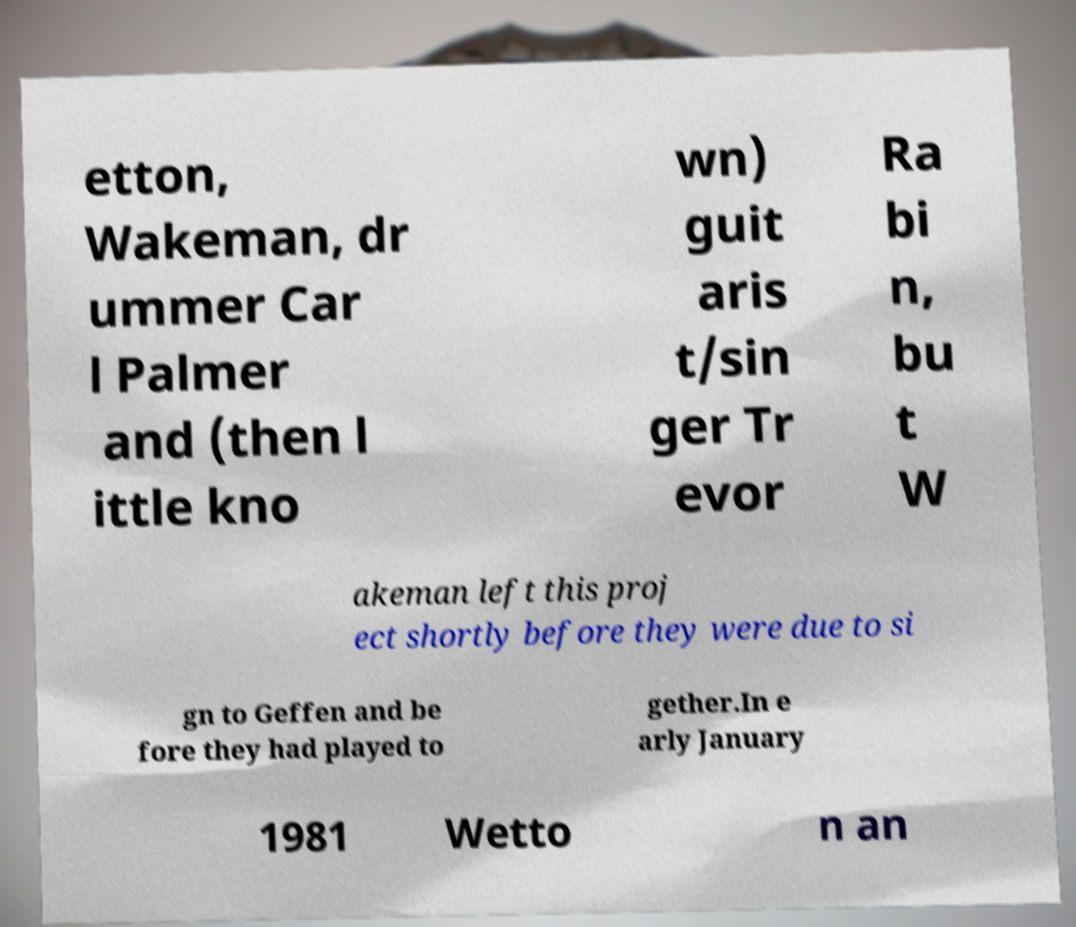For documentation purposes, I need the text within this image transcribed. Could you provide that? etton, Wakeman, dr ummer Car l Palmer and (then l ittle kno wn) guit aris t/sin ger Tr evor Ra bi n, bu t W akeman left this proj ect shortly before they were due to si gn to Geffen and be fore they had played to gether.In e arly January 1981 Wetto n an 